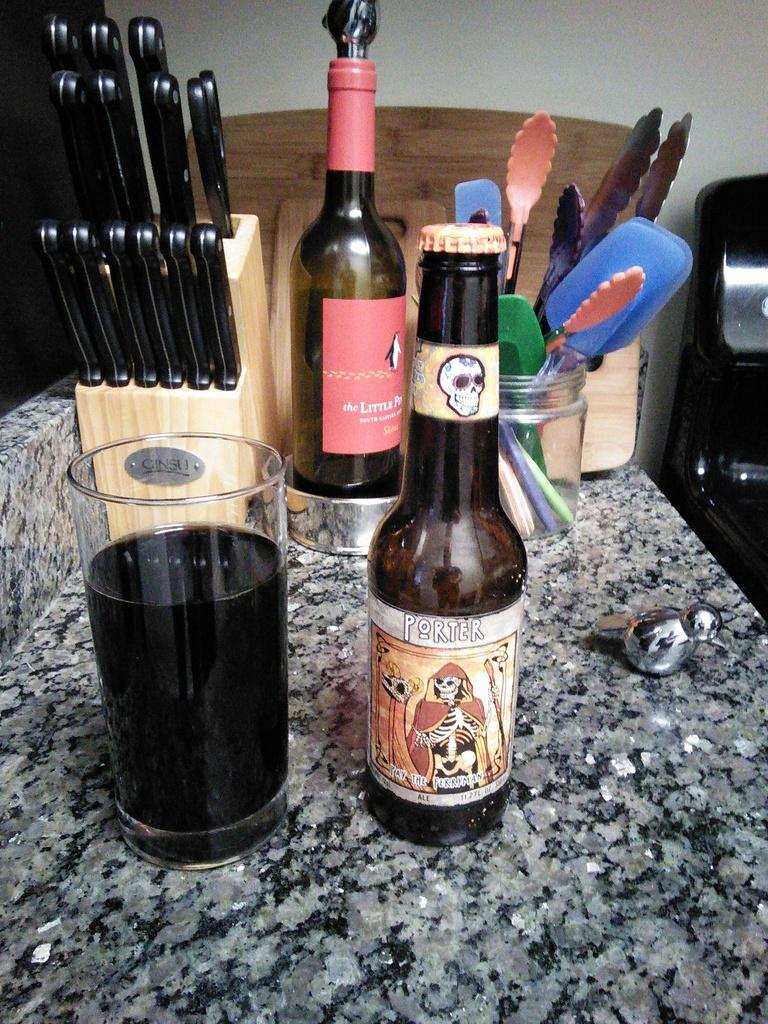<image>
Share a concise interpretation of the image provided. A bottle of Porter beer is on the counter. 